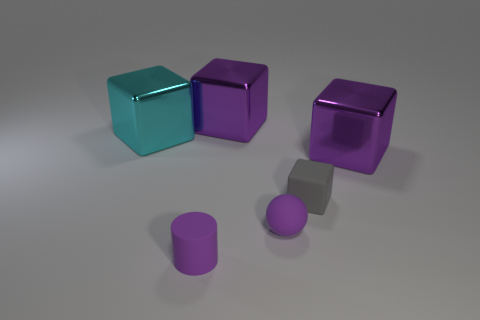What material is the small ball?
Offer a terse response. Rubber. Are there more purple objects in front of the cyan metallic cube than metal things left of the purple rubber cylinder?
Provide a short and direct response. Yes. What number of things are either matte objects or big cyan cylinders?
Your answer should be compact. 3. How many other things are there of the same color as the small cylinder?
Offer a very short reply. 3. What is the shape of the gray matte thing that is the same size as the ball?
Make the answer very short. Cube. What is the color of the metallic cube that is to the left of the cylinder?
Keep it short and to the point. Cyan. What number of things are either purple cubes that are to the right of the ball or large metallic blocks that are on the right side of the gray rubber thing?
Ensure brevity in your answer.  1. Do the purple sphere and the cyan thing have the same size?
Ensure brevity in your answer.  No. What number of balls are either large cyan metal things or metal objects?
Ensure brevity in your answer.  0. What number of things are both in front of the small gray thing and right of the tiny cylinder?
Your answer should be compact. 1. 